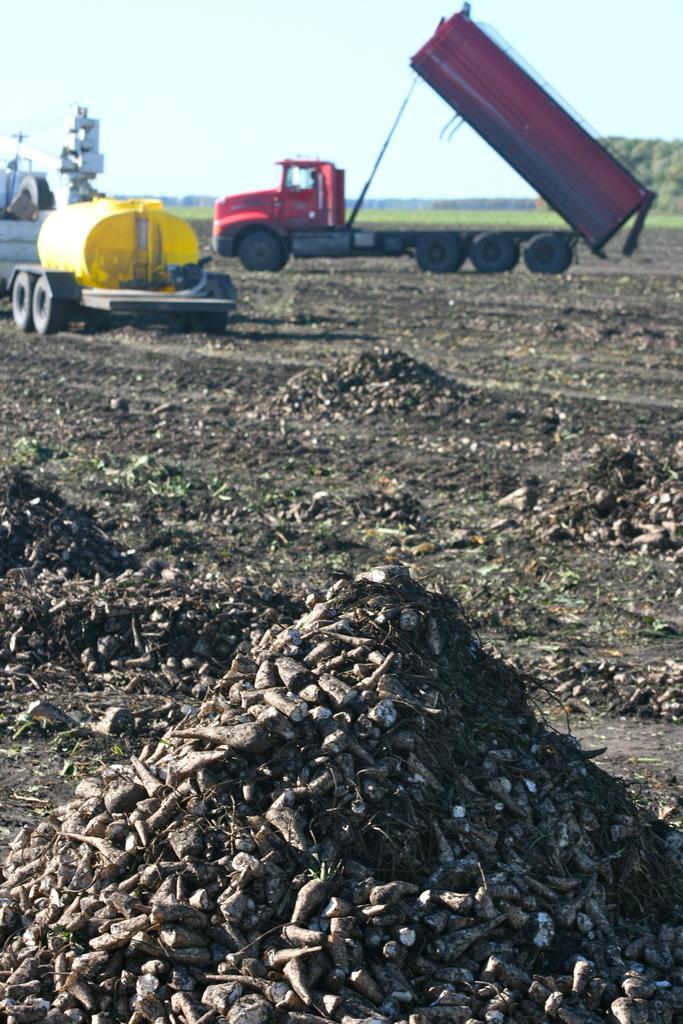Please provide a concise description of this image. In this image we can see two vehicles in the background and there is a ground. 